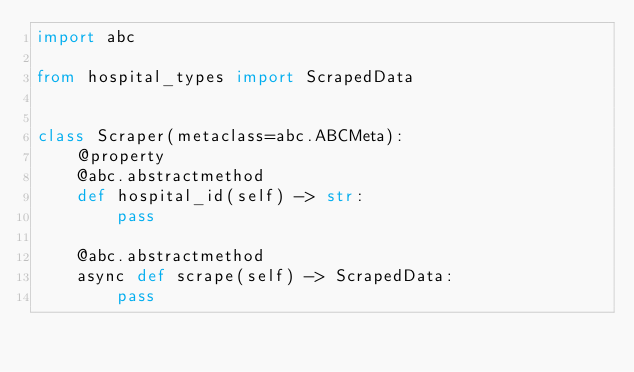<code> <loc_0><loc_0><loc_500><loc_500><_Python_>import abc

from hospital_types import ScrapedData


class Scraper(metaclass=abc.ABCMeta):
    @property
    @abc.abstractmethod
    def hospital_id(self) -> str:
        pass

    @abc.abstractmethod
    async def scrape(self) -> ScrapedData:
        pass
</code> 